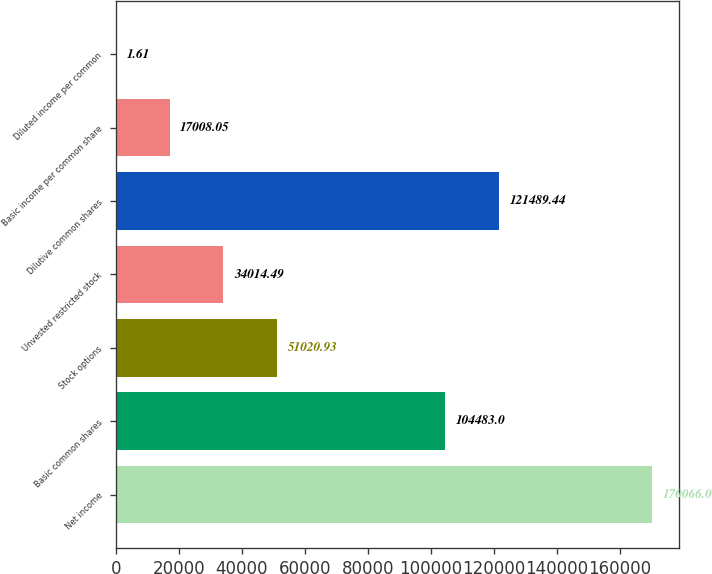Convert chart to OTSL. <chart><loc_0><loc_0><loc_500><loc_500><bar_chart><fcel>Net income<fcel>Basic common shares<fcel>Stock options<fcel>Unvested restricted stock<fcel>Dilutive common shares<fcel>Basic income per common share<fcel>Diluted income per common<nl><fcel>170066<fcel>104483<fcel>51020.9<fcel>34014.5<fcel>121489<fcel>17008<fcel>1.61<nl></chart> 